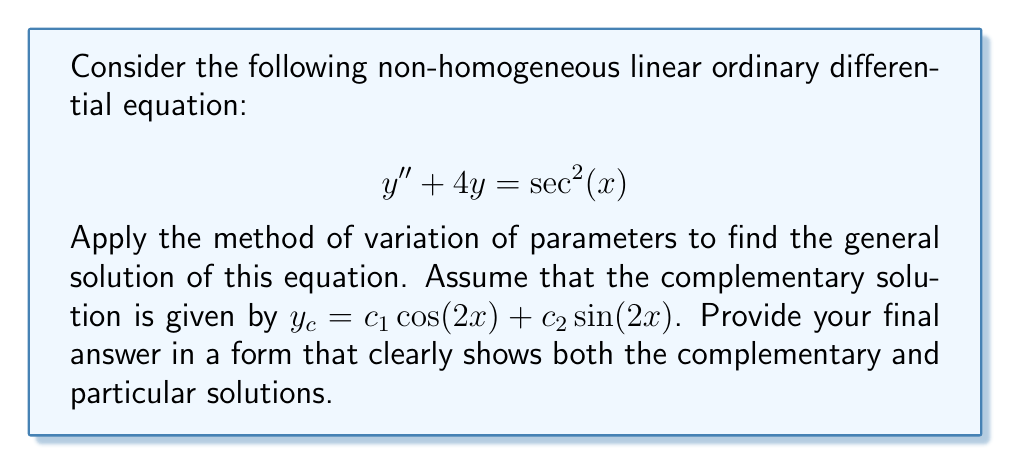What is the answer to this math problem? To solve this non-homogeneous ODE using the method of variation of parameters, we'll follow these steps:

1) We're given the complementary solution: $y_c = c_1 \cos(2x) + c_2 \sin(2x)$

2) Let's assume the particular solution has the form:
   $y_p = u_1(x)\cos(2x) + u_2(x)\sin(2x)$

3) We need to solve for $u_1'(x)$ and $u_2'(x)$ using these equations:
   $$ u_1'(x)\cos(2x) + u_2'(x)\sin(2x) = 0 $$
   $$ -2u_1'(x)\sin(2x) + 2u_2'(x)\cos(2x) = \sec^2(x) $$

4) Solving this system of equations:
   $$ u_1'(x) = -\frac{\sin(2x)}{2}\sec^2(x) $$
   $$ u_2'(x) = \frac{\cos(2x)}{2}\sec^2(x) $$

5) Integrate to find $u_1(x)$ and $u_2(x)$:
   $$ u_1(x) = -\int\frac{\sin(2x)}{2}\sec^2(x)dx = \frac{1}{4}\tan(x) $$
   $$ u_2(x) = \int\frac{\cos(2x)}{2}\sec^2(x)dx = \frac{1}{4}\ln|\sec(x)+\tan(x)| $$

6) The particular solution is:
   $$ y_p = \frac{1}{4}\tan(x)\cos(2x) + \frac{1}{4}\ln|\sec(x)+\tan(x)|\sin(2x) $$

7) The general solution is the sum of the complementary and particular solutions:
   $$ y = y_c + y_p $$
Answer: The general solution is:

$$ y = c_1 \cos(2x) + c_2 \sin(2x) + \frac{1}{4}\tan(x)\cos(2x) + \frac{1}{4}\ln|\sec(x)+\tan(x)|\sin(2x) $$

where $c_1$ and $c_2$ are arbitrary constants. 